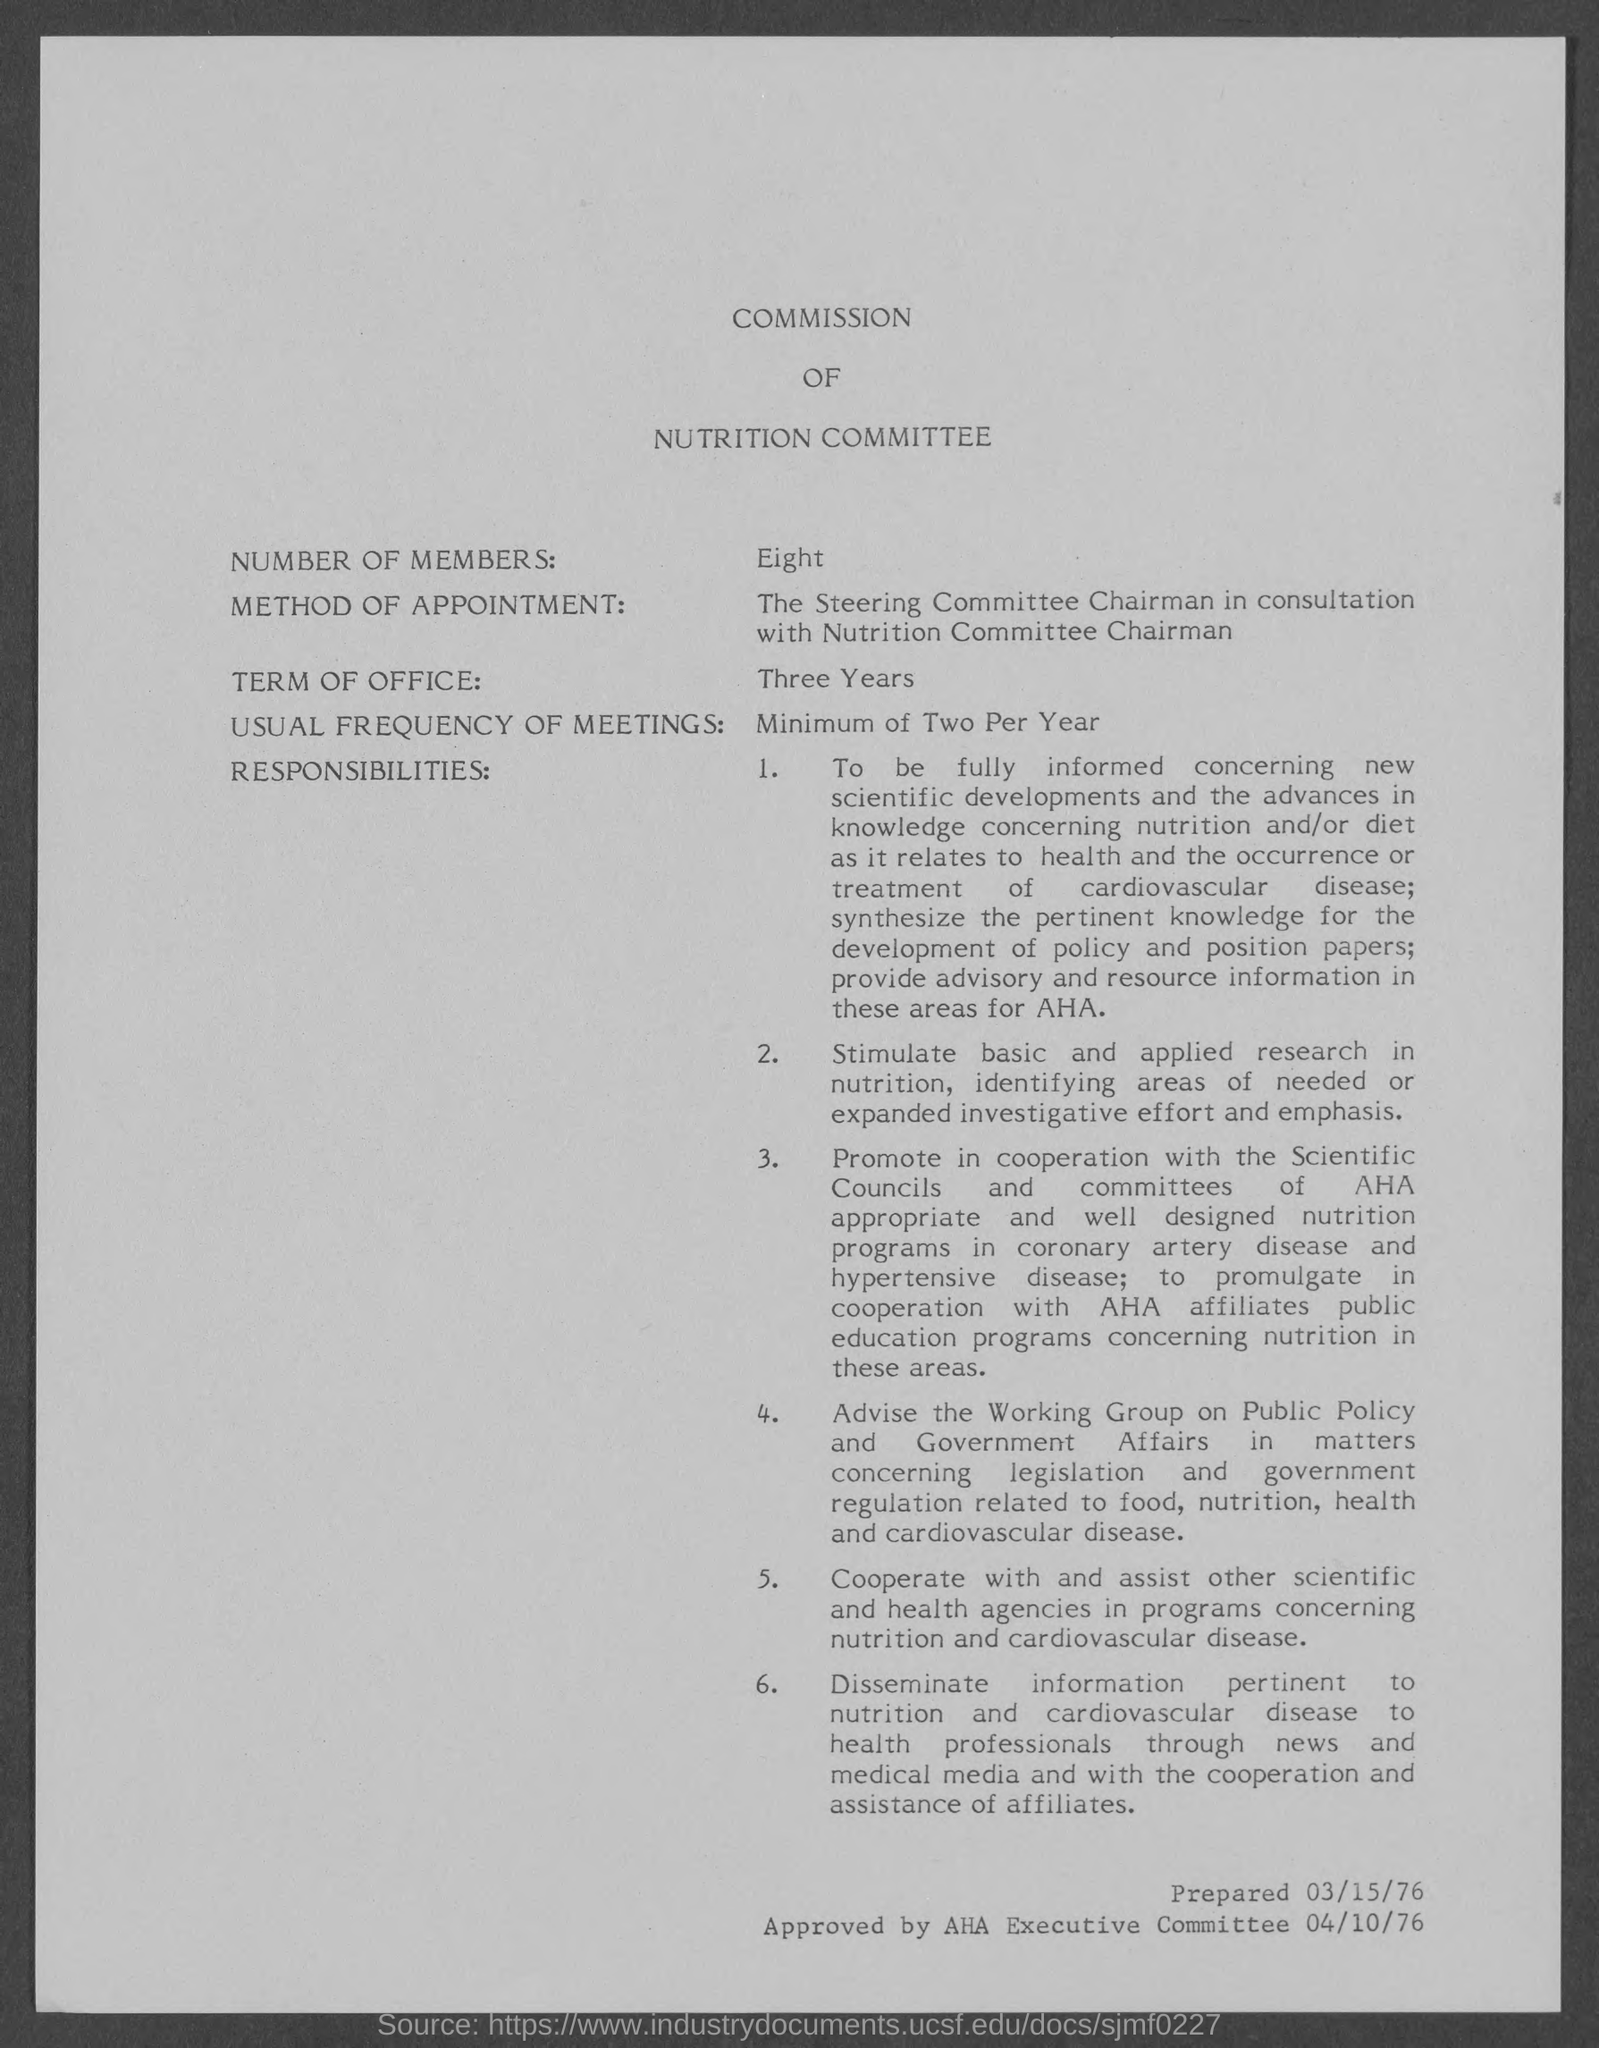What is the document title?
Provide a short and direct response. COMMISSION OF NUTRITION COMMITTEE. How many members are there?
Your response must be concise. Eight. What is the term of office?
Your answer should be very brief. Three Years. What is the usual frequency of meetings?
Your answer should be very brief. Minimum of Two Per Year. When was this document prepared?
Make the answer very short. 03/15/76. When was the document approved?
Ensure brevity in your answer.  04/10/76. Who has approved the document?
Provide a short and direct response. AHA Executive Committee. 